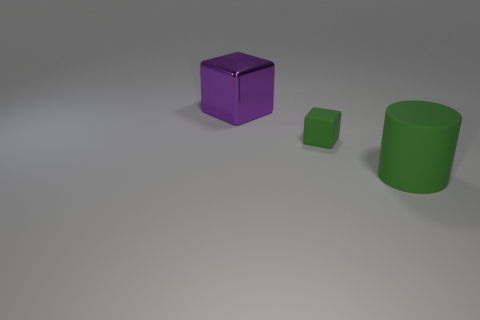Subtract all tiny yellow rubber objects. Subtract all small green matte blocks. How many objects are left? 2 Add 1 large blocks. How many large blocks are left? 2 Add 2 large purple cubes. How many large purple cubes exist? 3 Add 2 large green things. How many objects exist? 5 Subtract all green blocks. How many blocks are left? 1 Subtract 0 yellow cubes. How many objects are left? 3 Subtract all cylinders. How many objects are left? 2 Subtract 1 blocks. How many blocks are left? 1 Subtract all yellow cylinders. Subtract all green balls. How many cylinders are left? 1 Subtract all purple cylinders. How many red blocks are left? 0 